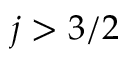<formula> <loc_0><loc_0><loc_500><loc_500>j > 3 / 2</formula> 